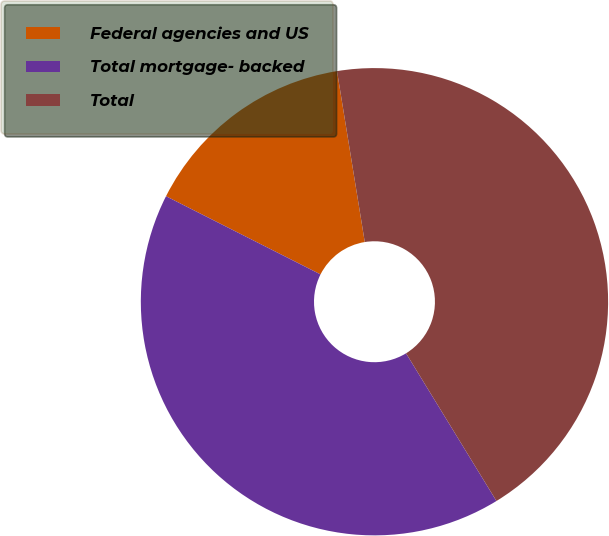Convert chart. <chart><loc_0><loc_0><loc_500><loc_500><pie_chart><fcel>Federal agencies and US<fcel>Total mortgage- backed<fcel>Total<nl><fcel>14.98%<fcel>41.2%<fcel>43.82%<nl></chart> 